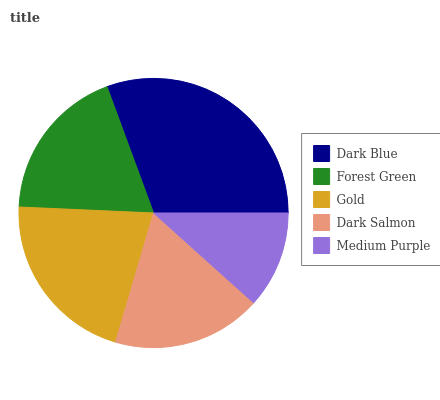Is Medium Purple the minimum?
Answer yes or no. Yes. Is Dark Blue the maximum?
Answer yes or no. Yes. Is Forest Green the minimum?
Answer yes or no. No. Is Forest Green the maximum?
Answer yes or no. No. Is Dark Blue greater than Forest Green?
Answer yes or no. Yes. Is Forest Green less than Dark Blue?
Answer yes or no. Yes. Is Forest Green greater than Dark Blue?
Answer yes or no. No. Is Dark Blue less than Forest Green?
Answer yes or no. No. Is Forest Green the high median?
Answer yes or no. Yes. Is Forest Green the low median?
Answer yes or no. Yes. Is Gold the high median?
Answer yes or no. No. Is Medium Purple the low median?
Answer yes or no. No. 